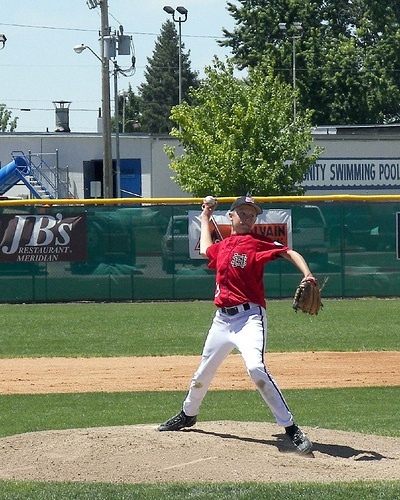Describe the objects in this image and their specific colors. I can see people in lightblue, maroon, white, darkgray, and black tones, truck in lightblue, black, and teal tones, car in lightblue, black, and teal tones, car in lightblue, black, and teal tones, and truck in lightblue, teal, and black tones in this image. 